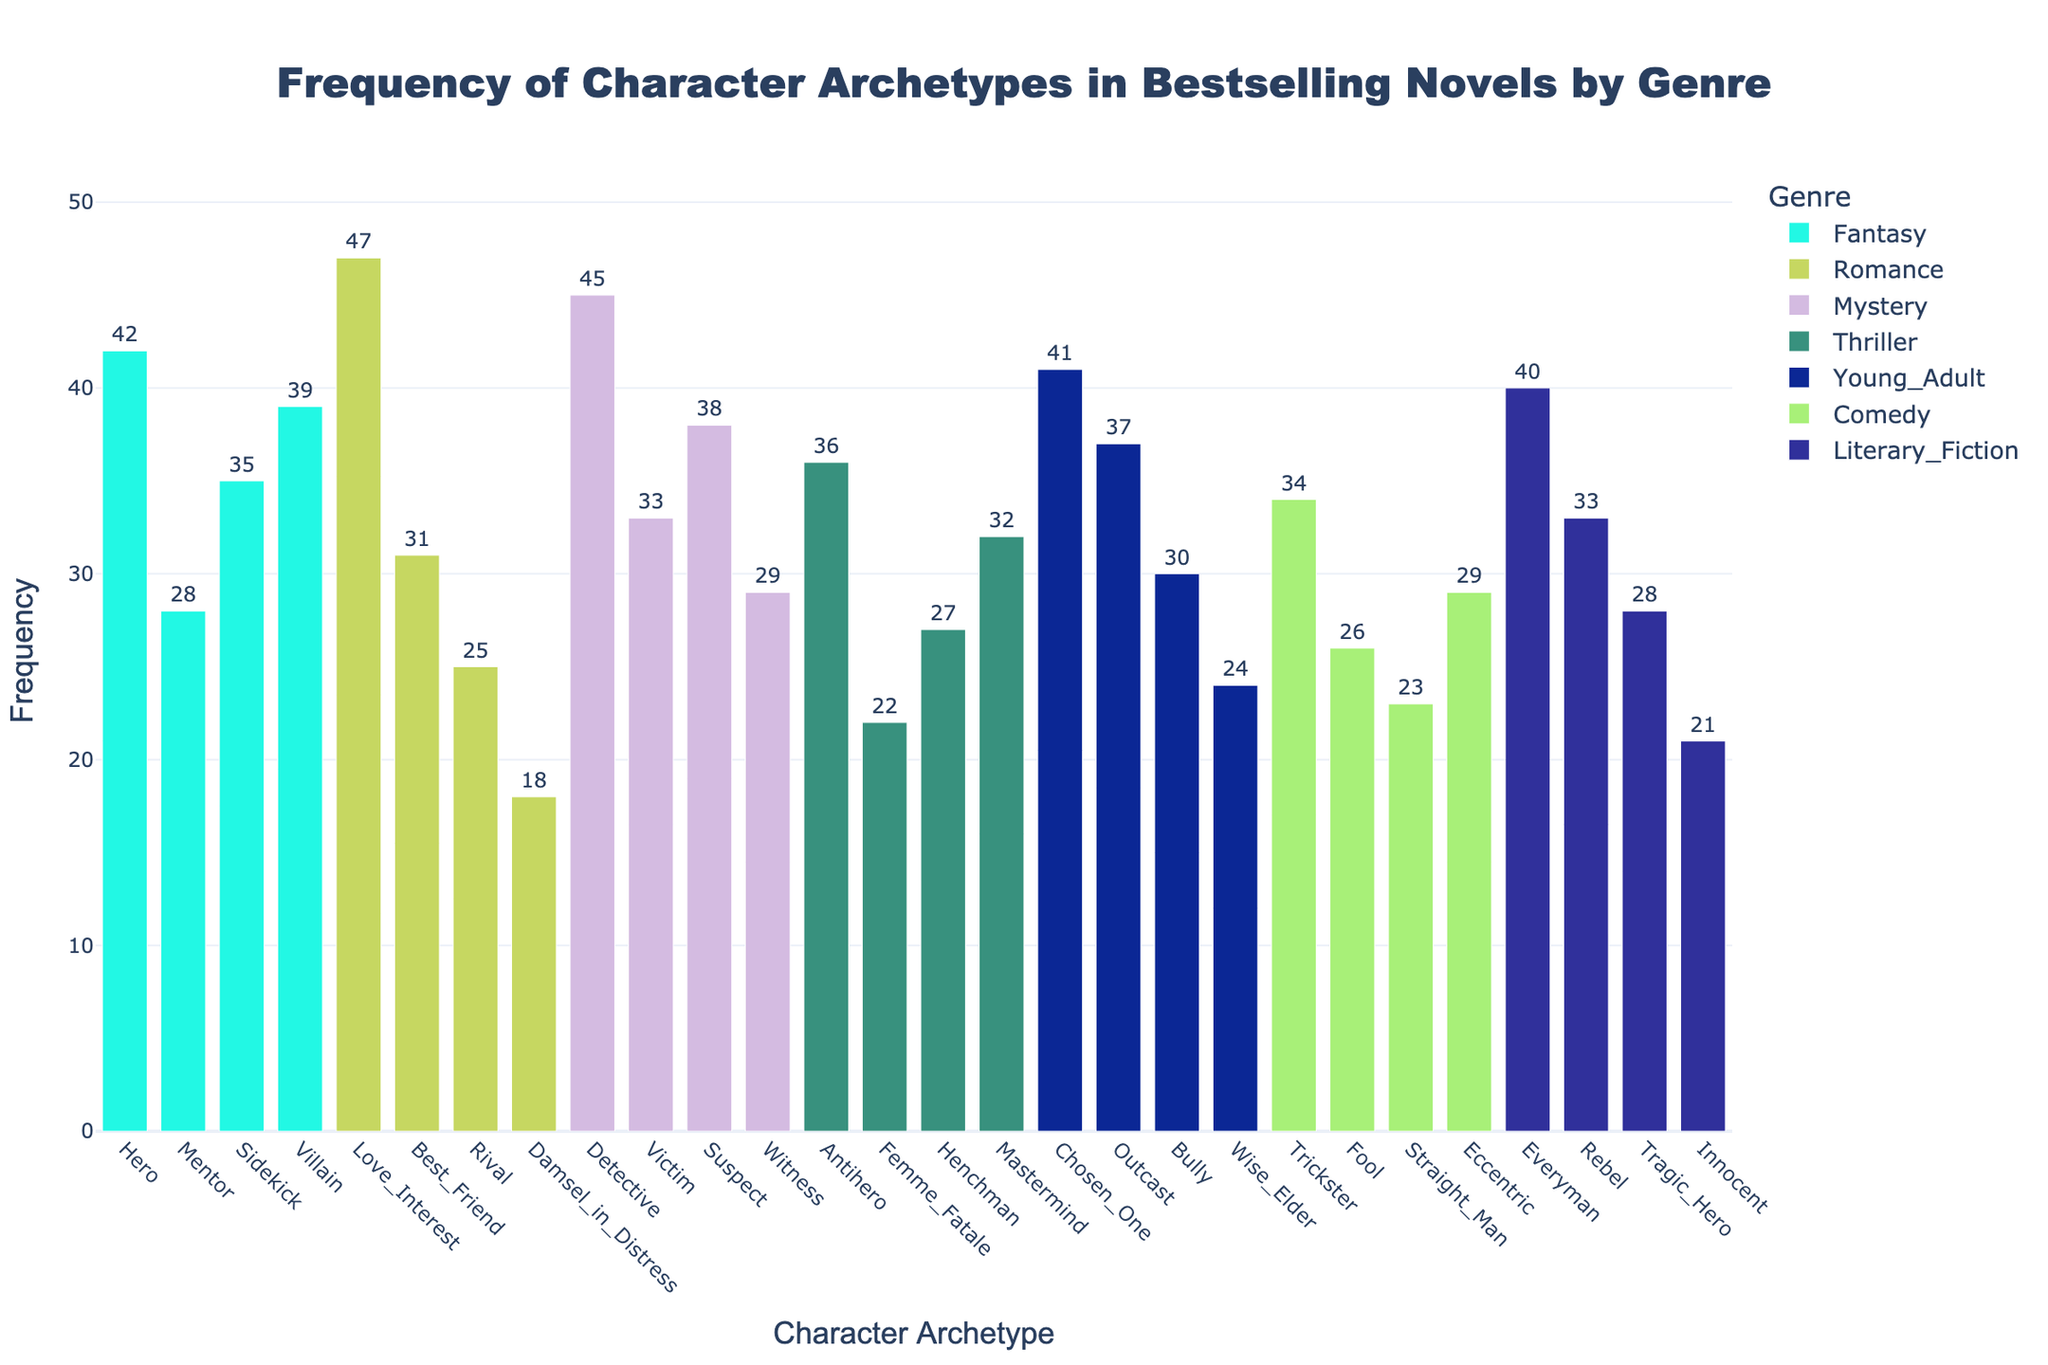What is the frequency of the Hero archetype in Fantasy? The Hero archetype is listed under Fantasy with a corresponding frequency value. Locate the bar for Hero within the Fantasy group to find its frequency.
Answer: 42 Which genre has the character archetype with the highest frequency, and what is it? Look for the tallest bar in the plot across all genres, then identify the genre and archetype from the hover text or labels.
Answer: Romance, Love Interest How many character archetypes have a frequency greater than 30 in Mystery? Identify the bars in the Mystery genre and count those with a frequency value higher than 30.
Answer: 3 What is the combined frequency of the Mentor and Sidekick archetypes in Fantasy? Locate the bars for Mentor and Sidekick within the Fantasy group, add their frequencies together. Mentor: 28, Sidekick: 35. Combined: 28 + 35.
Answer: 63 Which character archetype in Thriller has the lowest frequency? Look for the shortest bar in the Thriller group, and read the archetype label and its frequency.
Answer: Femme Fatale Compare the frequency of the Bully archetype in Young Adult and the Tragic Hero archetype in Literary Fiction. Which is higher? Find the bars for Bully in Young Adult and Tragic Hero in Literary Fiction. Compare their frequencies. Bully: 30, Tragic Hero: 28.
Answer: Bully What is the average frequency of character archetypes in Comedy? Identify all bars within the Comedy genre and calculate the average of their frequencies. (34 + 26 + 23 + 29) / 4.
Answer: 28 If you sum the frequencies of the most and least common archetypes in Romance, what is the total? Identify the highest and lowest frequency bars in the Romance genre. Add their frequencies together. Most: Love Interest 47, Least: Damsel in Distress 18. Total: 47 + 18.
Answer: 65 By how much does the frequency of the Chosen One archetype in Young Adult exceed the frequency of the Wise Elder archetype in the same genre? Locate the bars for Chosen One and Wise Elder in Young Adult, then subtract the smaller frequency from the larger one. Chosen One: 41, Wise Elder: 24. Difference: 41 - 24.
Answer: 17 